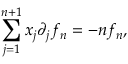<formula> <loc_0><loc_0><loc_500><loc_500>\sum _ { j = 1 } ^ { n + 1 } x _ { j } \partial _ { j } f _ { n } = - n f _ { n } ,</formula> 